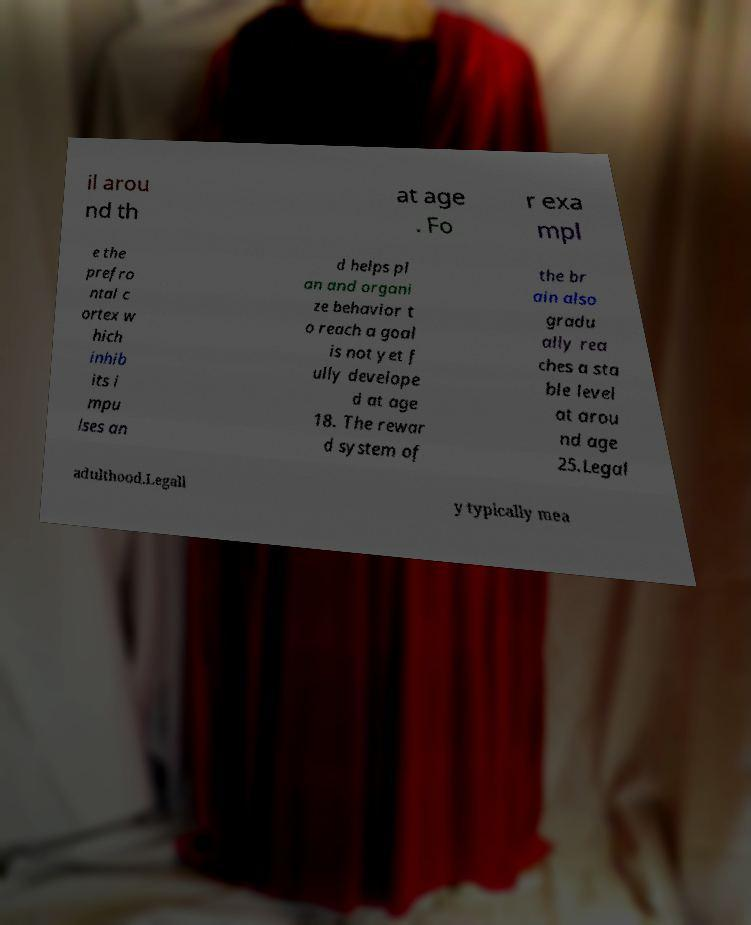I need the written content from this picture converted into text. Can you do that? il arou nd th at age . Fo r exa mpl e the prefro ntal c ortex w hich inhib its i mpu lses an d helps pl an and organi ze behavior t o reach a goal is not yet f ully develope d at age 18. The rewar d system of the br ain also gradu ally rea ches a sta ble level at arou nd age 25.Legal adulthood.Legall y typically mea 